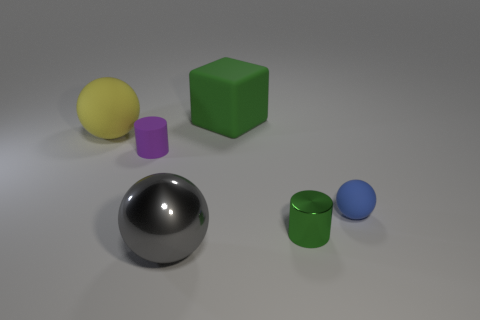Add 4 big blue rubber cylinders. How many objects exist? 10 Subtract all blocks. How many objects are left? 5 Add 5 small spheres. How many small spheres exist? 6 Subtract 0 cyan cylinders. How many objects are left? 6 Subtract all small purple matte things. Subtract all gray things. How many objects are left? 4 Add 5 large gray metallic things. How many large gray metallic things are left? 6 